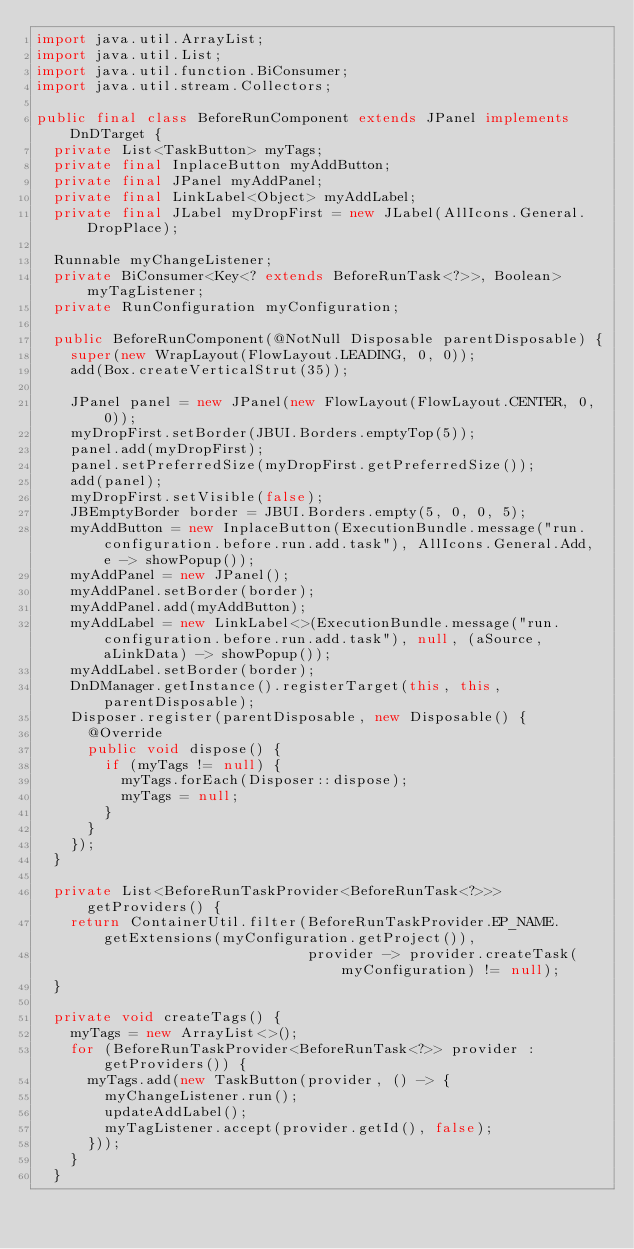<code> <loc_0><loc_0><loc_500><loc_500><_Java_>import java.util.ArrayList;
import java.util.List;
import java.util.function.BiConsumer;
import java.util.stream.Collectors;

public final class BeforeRunComponent extends JPanel implements DnDTarget {
  private List<TaskButton> myTags;
  private final InplaceButton myAddButton;
  private final JPanel myAddPanel;
  private final LinkLabel<Object> myAddLabel;
  private final JLabel myDropFirst = new JLabel(AllIcons.General.DropPlace);

  Runnable myChangeListener;
  private BiConsumer<Key<? extends BeforeRunTask<?>>, Boolean> myTagListener;
  private RunConfiguration myConfiguration;

  public BeforeRunComponent(@NotNull Disposable parentDisposable) {
    super(new WrapLayout(FlowLayout.LEADING, 0, 0));
    add(Box.createVerticalStrut(35));

    JPanel panel = new JPanel(new FlowLayout(FlowLayout.CENTER, 0, 0));
    myDropFirst.setBorder(JBUI.Borders.emptyTop(5));
    panel.add(myDropFirst);
    panel.setPreferredSize(myDropFirst.getPreferredSize());
    add(panel);
    myDropFirst.setVisible(false);
    JBEmptyBorder border = JBUI.Borders.empty(5, 0, 0, 5);
    myAddButton = new InplaceButton(ExecutionBundle.message("run.configuration.before.run.add.task"), AllIcons.General.Add, e -> showPopup());
    myAddPanel = new JPanel();
    myAddPanel.setBorder(border);
    myAddPanel.add(myAddButton);
    myAddLabel = new LinkLabel<>(ExecutionBundle.message("run.configuration.before.run.add.task"), null, (aSource, aLinkData) -> showPopup());
    myAddLabel.setBorder(border);
    DnDManager.getInstance().registerTarget(this, this, parentDisposable);
    Disposer.register(parentDisposable, new Disposable() {
      @Override
      public void dispose() {
        if (myTags != null) {
          myTags.forEach(Disposer::dispose);
          myTags = null;
        }
      }
    });
  }

  private List<BeforeRunTaskProvider<BeforeRunTask<?>>> getProviders() {
    return ContainerUtil.filter(BeforeRunTaskProvider.EP_NAME.getExtensions(myConfiguration.getProject()),
                                provider -> provider.createTask(myConfiguration) != null);
  }

  private void createTags() {
    myTags = new ArrayList<>();
    for (BeforeRunTaskProvider<BeforeRunTask<?>> provider : getProviders()) {
      myTags.add(new TaskButton(provider, () -> {
        myChangeListener.run();
        updateAddLabel();
        myTagListener.accept(provider.getId(), false);
      }));
    }
  }
</code> 